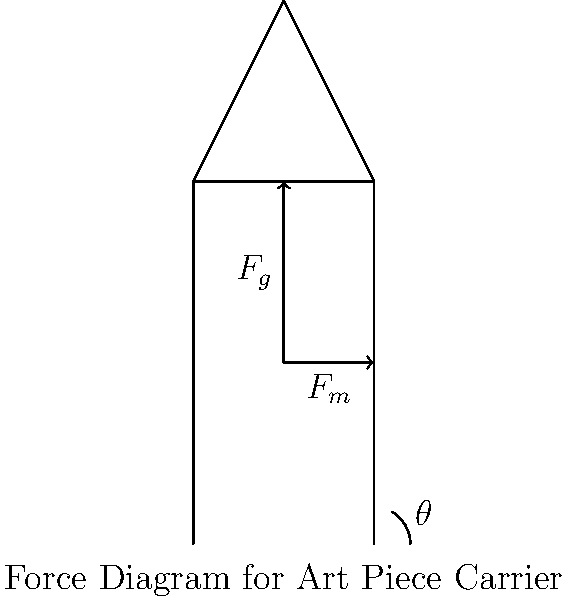An art handler needs to carry a heavy sculpture weighing 500 N. To minimize back strain, they lean forward at an angle $\theta$ from the vertical. If the muscles in their lower back exert a force $F_m$ at an angle of 12° to the horizontal, what should be the optimal angle $\theta$ to minimize the muscle force $F_m$? To find the optimal angle $\theta$, we need to minimize the muscle force $F_m$. Let's approach this step-by-step:

1) First, let's establish the equilibrium equations:
   Vertical: $F_m \sin(12°) = F_g = 500 N$
   Horizontal: $F_m \cos(12°) = F_g \tan(\theta)$

2) From the vertical equation:
   $F_m = \frac{500}{\sin(12°)}$

3) Substituting this into the horizontal equation:
   $\frac{500}{\sin(12°)} \cos(12°) = 500 \tan(\theta)$

4) Simplifying:
   $\frac{\cos(12°)}{\sin(12°)} = \tan(\theta)$

5) The left side is the definition of $\cot(12°)$, so:
   $\cot(12°) = \tan(\theta)$

6) For this equality to hold:
   $\theta + 12° = 90°$
   $\theta = 78°$

7) To verify this is a minimum, we could take the derivative of $F_m$ with respect to $\theta$ and show it equals zero at this point, but that's beyond the scope of this question.

Therefore, the optimal angle $\theta$ for the art handler to lean forward is 78° from the vertical.
Answer: 78° 